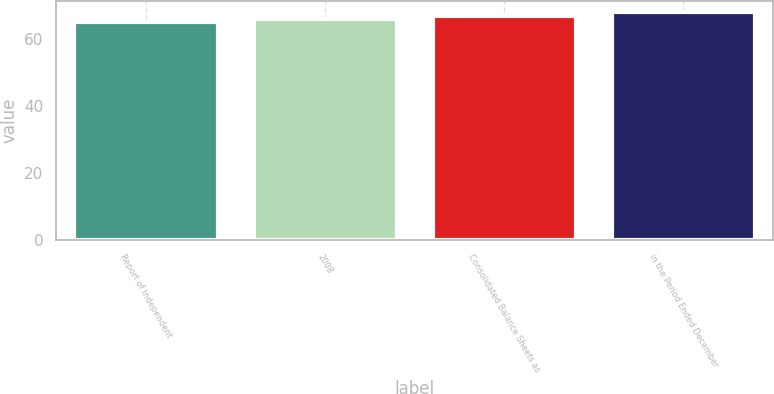Convert chart. <chart><loc_0><loc_0><loc_500><loc_500><bar_chart><fcel>Report of Independent<fcel>2008<fcel>Consolidated Balance Sheets as<fcel>in the Period Ended December<nl><fcel>65<fcel>66<fcel>67<fcel>68<nl></chart> 